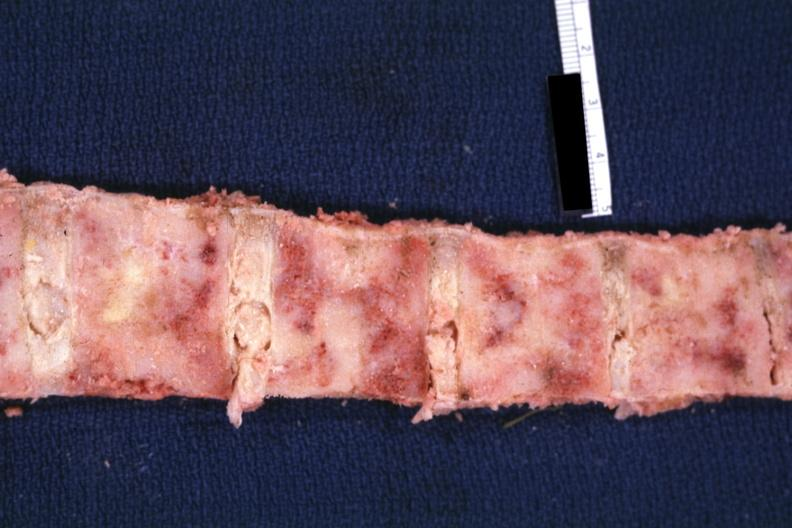what does this image show?
Answer the question using a single word or phrase. Bone nearly completely filled with tumor primary probably is lung 